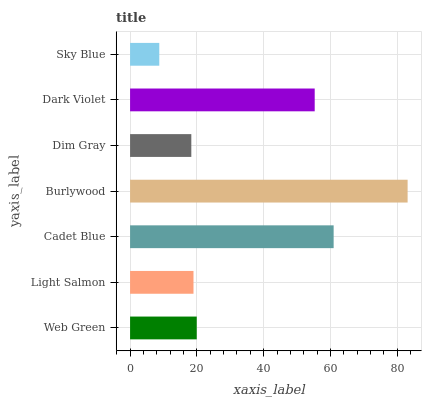Is Sky Blue the minimum?
Answer yes or no. Yes. Is Burlywood the maximum?
Answer yes or no. Yes. Is Light Salmon the minimum?
Answer yes or no. No. Is Light Salmon the maximum?
Answer yes or no. No. Is Web Green greater than Light Salmon?
Answer yes or no. Yes. Is Light Salmon less than Web Green?
Answer yes or no. Yes. Is Light Salmon greater than Web Green?
Answer yes or no. No. Is Web Green less than Light Salmon?
Answer yes or no. No. Is Web Green the high median?
Answer yes or no. Yes. Is Web Green the low median?
Answer yes or no. Yes. Is Burlywood the high median?
Answer yes or no. No. Is Light Salmon the low median?
Answer yes or no. No. 